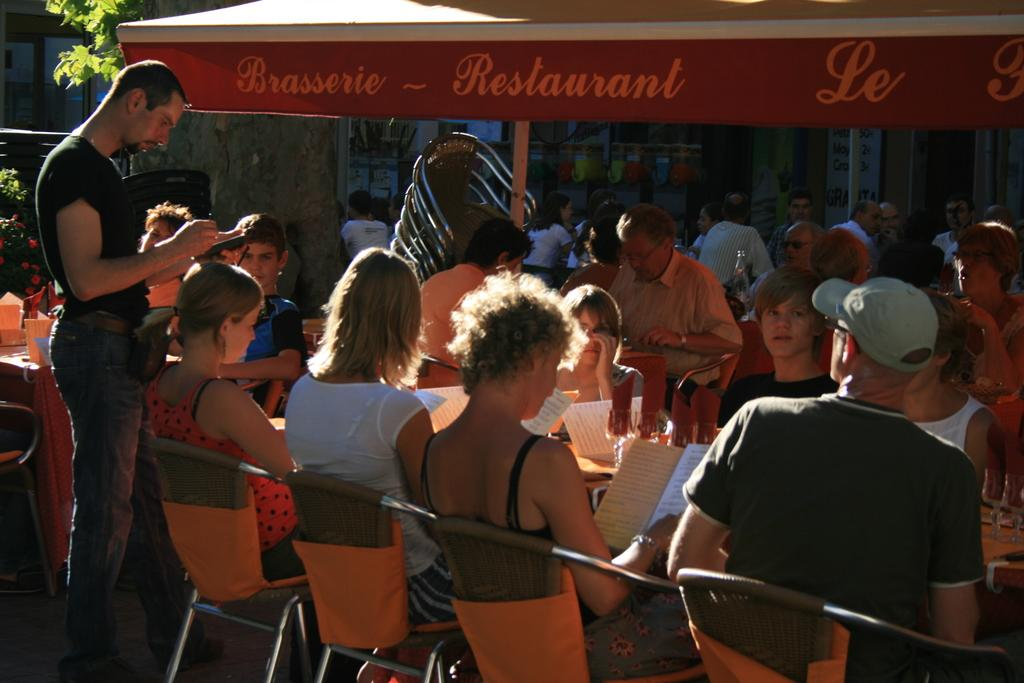How many people are in the image? There are multiple people in the image. What are the people doing in the image? The people are sitting on chairs. Is there anyone standing in the image? Yes, there is a man standing in the image. What type of disease is affecting the people in the image? There is no indication of any disease affecting the people in the image. Is this a family gathering, based on the people in the image? The image does not provide any information about the relationships between the people, so it cannot be determined if it is a family gathering. 